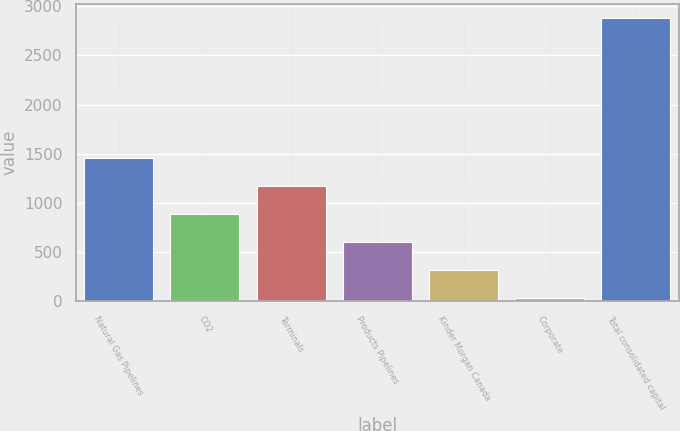Convert chart. <chart><loc_0><loc_0><loc_500><loc_500><bar_chart><fcel>Natural Gas Pipelines<fcel>CO2<fcel>Terminals<fcel>Products Pipelines<fcel>Kinder Morgan Canada<fcel>Corporate<fcel>Total consolidated capital<nl><fcel>1455<fcel>884.2<fcel>1169.6<fcel>598.8<fcel>313.4<fcel>28<fcel>2882<nl></chart> 